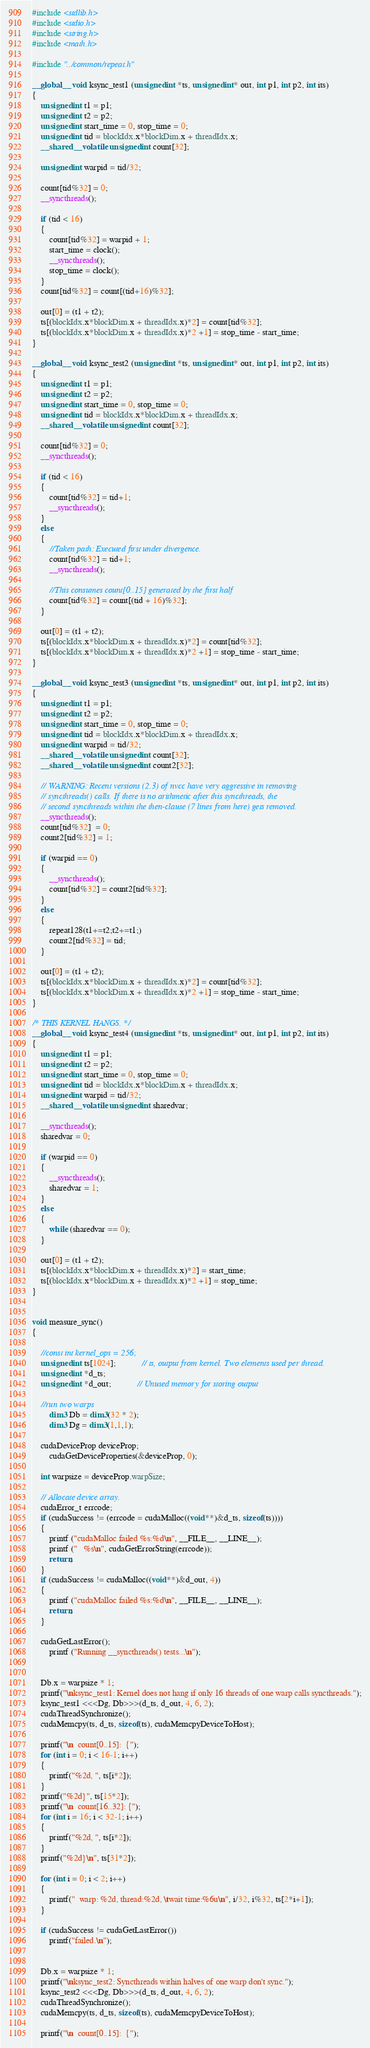<code> <loc_0><loc_0><loc_500><loc_500><_Cuda_>#include <stdlib.h>
#include <stdio.h>
#include <string.h>
#include <math.h>

#include "../common/repeat.h"

__global__ void ksync_test1 (unsigned int *ts, unsigned int* out, int p1, int p2, int its)
{
	unsigned int t1 = p1;
	unsigned int t2 = p2;
	unsigned int start_time = 0, stop_time = 0;
	unsigned int tid = blockIdx.x*blockDim.x + threadIdx.x;
	__shared__ volatile unsigned int count[32];

	unsigned int warpid = tid/32;
	
	count[tid%32] = 0;
	__syncthreads();

	if (tid < 16)
	{
		count[tid%32] = warpid + 1;
		start_time = clock();
		__syncthreads();
		stop_time = clock();
	}
	count[tid%32] = count[(tid+16)%32];

	out[0] = (t1 + t2); 
	ts[(blockIdx.x*blockDim.x + threadIdx.x)*2] = count[tid%32];
	ts[(blockIdx.x*blockDim.x + threadIdx.x)*2 +1] = stop_time - start_time;
}

__global__ void ksync_test2 (unsigned int *ts, unsigned int* out, int p1, int p2, int its)
{
	unsigned int t1 = p1;
	unsigned int t2 = p2;
	unsigned int start_time = 0, stop_time = 0;
	unsigned int tid = blockIdx.x*blockDim.x + threadIdx.x;
	__shared__ volatile unsigned int count[32];

	count[tid%32] = 0;
	__syncthreads();

	if (tid < 16)
	{
		count[tid%32] = tid+1;
		__syncthreads();
	}
	else 
	{
		//Taken path: Executed first under divergence.
		count[tid%32] = tid+1;
		__syncthreads();

		//This consumes count[0..15] generated by the first half
		count[tid%32] = count[(tid + 16)%32];	
	}

	out[0] = (t1 + t2); 
	ts[(blockIdx.x*blockDim.x + threadIdx.x)*2] = count[tid%32];
	ts[(blockIdx.x*blockDim.x + threadIdx.x)*2 +1] = stop_time - start_time;
}

__global__ void ksync_test3 (unsigned int *ts, unsigned int* out, int p1, int p2, int its)
{
	unsigned int t1 = p1;
	unsigned int t2 = p2;
	unsigned int start_time = 0, stop_time = 0;
	unsigned int tid = blockIdx.x*blockDim.x + threadIdx.x;
	unsigned int warpid = tid/32;
	__shared__ volatile unsigned int count[32];
	__shared__ volatile unsigned int count2[32];

	// WARNING: Recent versions (2.3) of nvcc have very aggressive in removing
	// syncthreads() calls. If there is no arithmetic after this syncthreads, the
	// second syncthreads within the then-clause (7 lines from here) gets removed.
	__syncthreads();
	count[tid%32]  = 0;
	count2[tid%32] = 1;

	if (warpid == 0)
	{
		__syncthreads();
		count[tid%32] = count2[tid%32]; 
	}
	else 
	{
		repeat128(t1+=t2;t2+=t1;)
		count2[tid%32] = tid;
	}

	out[0] = (t1 + t2); 
	ts[(blockIdx.x*blockDim.x + threadIdx.x)*2] = count[tid%32];
	ts[(blockIdx.x*blockDim.x + threadIdx.x)*2 +1] = stop_time - start_time;
}

/* THIS KERNEL HANGS. */
__global__ void ksync_test4 (unsigned int *ts, unsigned int* out, int p1, int p2, int its)
{
	unsigned int t1 = p1;
	unsigned int t2 = p2;
	unsigned int start_time = 0, stop_time = 0;
	unsigned int tid = blockIdx.x*blockDim.x + threadIdx.x;
	unsigned int warpid = tid/32;
	__shared__ volatile unsigned int sharedvar;

	__syncthreads();
	sharedvar = 0;

	if (warpid == 0)
	{
		__syncthreads();
		sharedvar = 1;
	}
	else 
	{
		while (sharedvar == 0);
	}

	out[0] = (t1 + t2); 
	ts[(blockIdx.x*blockDim.x + threadIdx.x)*2] = start_time; 
	ts[(blockIdx.x*blockDim.x + threadIdx.x)*2 +1] = stop_time;
}


void measure_sync()
{

	//const int kernel_ops = 256;
	unsigned int ts[1024];			// ts, output from kernel. Two elements used per thread.
	unsigned int *d_ts;
	unsigned int *d_out;			// Unused memory for storing output

	//run two warps
    	dim3 Db = dim3(32 * 2);
    	dim3 Dg = dim3(1,1,1);
	
	cudaDeviceProp deviceProp;
        cudaGetDeviceProperties(&deviceProp, 0);

	int warpsize = deviceProp.warpSize;

	// Allocate device array.
	cudaError_t errcode;
	if (cudaSuccess != (errcode = cudaMalloc((void**)&d_ts, sizeof(ts))))
	{
		printf ("cudaMalloc failed %s:%d\n", __FILE__, __LINE__);
		printf ("   %s\n", cudaGetErrorString(errcode));
		return;
	}
	if (cudaSuccess != cudaMalloc((void**)&d_out, 4))
	{
		printf ("cudaMalloc failed %s:%d\n", __FILE__, __LINE__);
		return;
	}

	cudaGetLastError();
    	printf ("Running __syncthreads() tests...\n");
	

	Db.x = warpsize * 1;
	printf("\nksync_test1: Kernel does not hang if only 16 threads of one warp calls syncthreads.");
	ksync_test1 <<<Dg, Db>>>(d_ts, d_out, 4, 6, 2);
	cudaThreadSynchronize();
	cudaMemcpy(ts, d_ts, sizeof(ts), cudaMemcpyDeviceToHost);

	printf("\n  count[0..15]:  {");
	for (int i = 0; i < 16-1; i++)
	{
		printf("%2d, ", ts[i*2]);
	}
	printf("%2d}", ts[15*2]);
	printf("\n  count[16..32]: {");
	for (int i = 16; i < 32-1; i++)
	{
		printf("%2d, ", ts[i*2]);
	}
	printf("%2d}\n", ts[31*2]);

	for (int i = 0; i < 2; i++)
	{
		printf("  warp: %2d, thread:%2d, \twait time:%6u\n", i/32, i%32, ts[2*i+1]);
	}

	if (cudaSuccess != cudaGetLastError())
		printf("failed.\n");


	Db.x = warpsize * 1;
	printf("\nksync_test2: Syncthreads within halves of one warp don't sync.");
	ksync_test2 <<<Dg, Db>>>(d_ts, d_out, 4, 6, 2);
	cudaThreadSynchronize();
	cudaMemcpy(ts, d_ts, sizeof(ts), cudaMemcpyDeviceToHost);

	printf("\n  count[0..15]:  {");</code> 